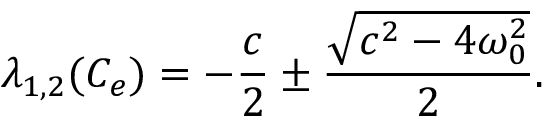Convert formula to latex. <formula><loc_0><loc_0><loc_500><loc_500>\lambda _ { 1 , 2 } ( C _ { e } ) = - \frac { c } { 2 } \pm \frac { \sqrt { c ^ { 2 } - 4 \omega _ { 0 } ^ { 2 } } } { 2 } .</formula> 